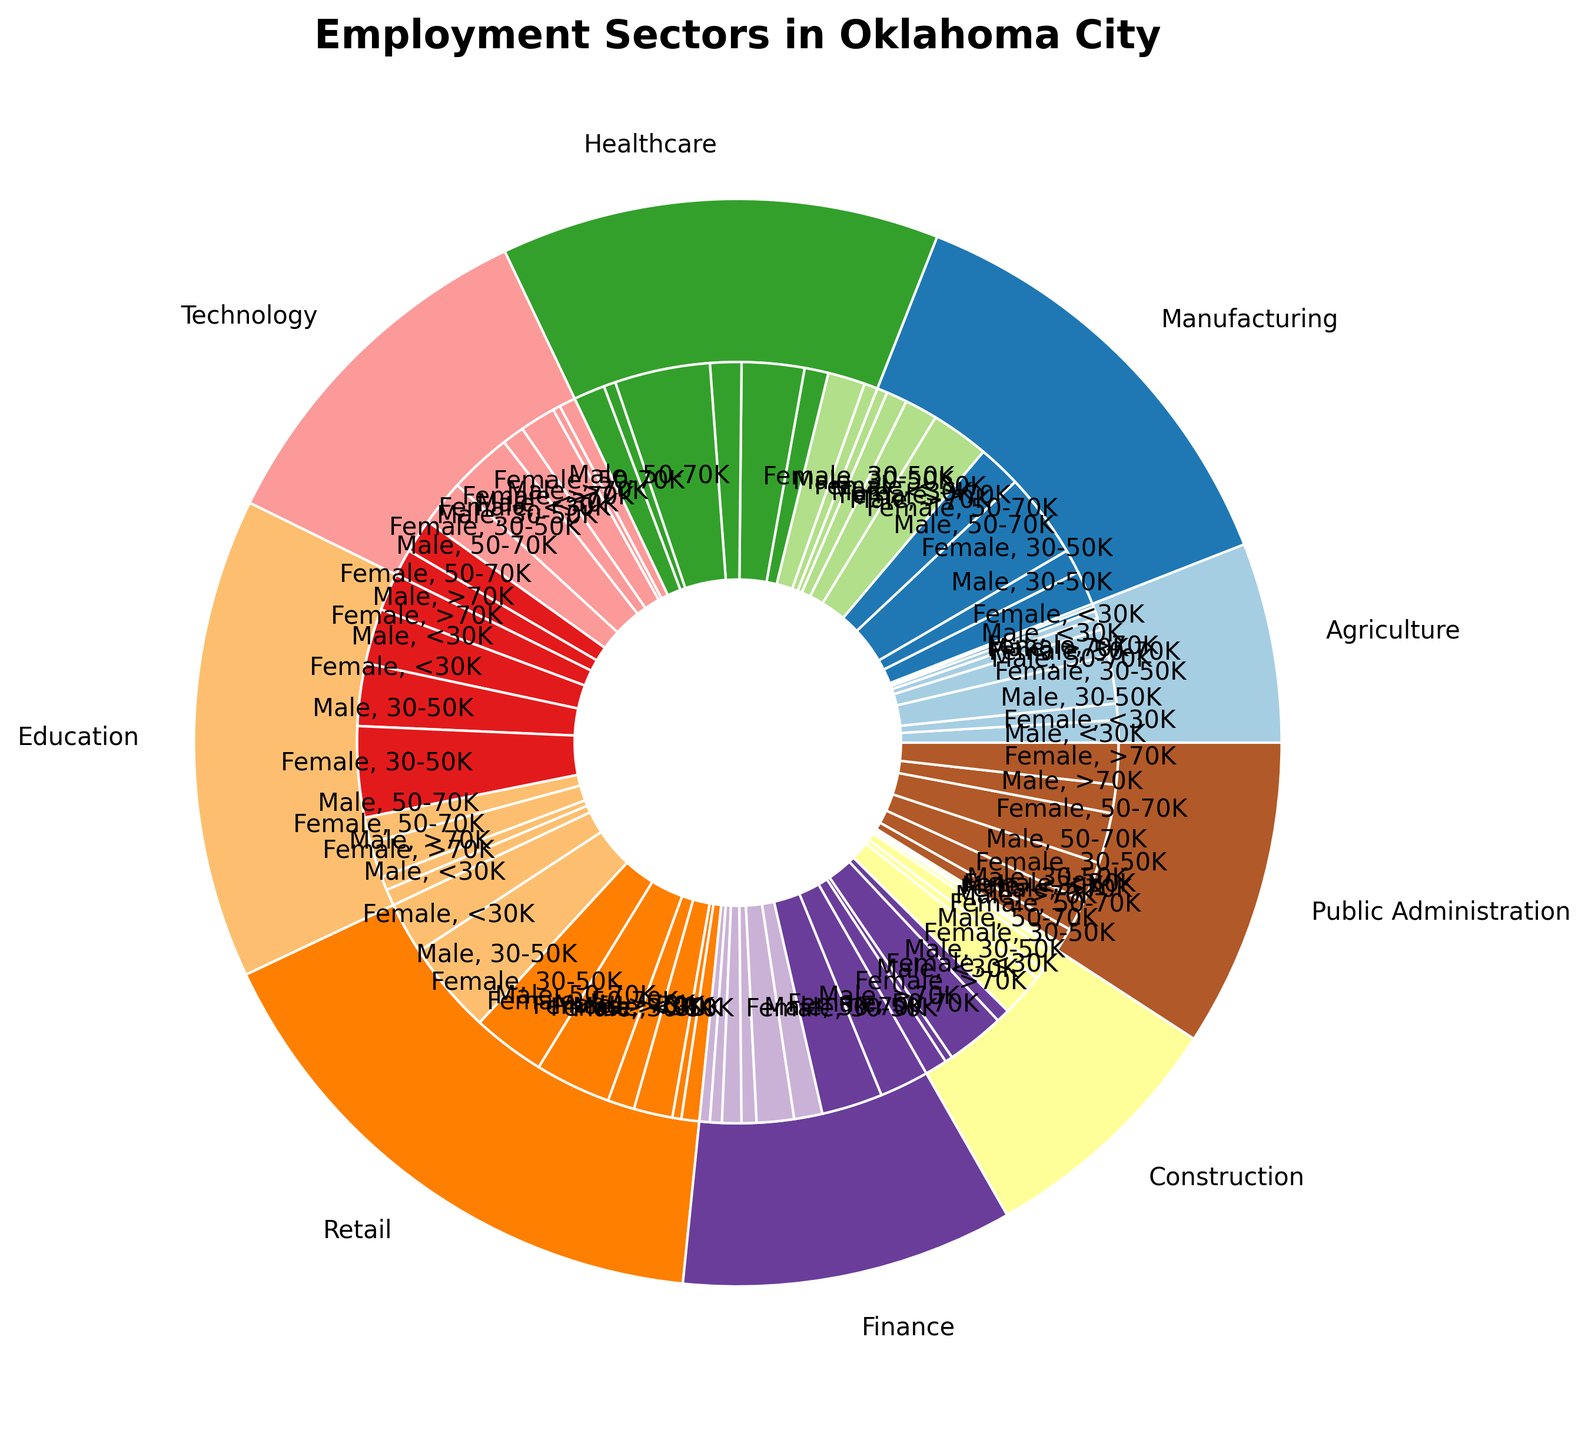How much higher is the representation of males earning above 70K in Finance compared to Construction? First, find the percentage for males earning above 70K in both sectors from the chart. Finance: 4.1%. Construction: 1.2%. Subtract the smaller percentage from the larger one: 4.1% - 1.2% = 2.9%.
Answer: 2.9% In which sector are females earning 30-50K more represented than males? Identify sectors in the chart where the percentage for females in the 30-50K range is higher than that for males. Females are more represented in Education (6.1% vs 4.2%), Healthcare (4.2% vs 1.6%), and Retail (5.1% vs 4.9%).
Answer: Education, Healthcare, Retail Which sector has the smallest overall representation in Oklahoma City? Sum the percentages for all sectors and compare them. Public Administration has the smallest sector sum of 10.3%.
Answer: Public Administration What is the most represented sector for females under 30K? Find the sector with the highest percentage of females earning under 30K by comparing the figures in the chart. Retail has the highest at 6.2%.
Answer: Retail What's the total percentage of people working in Healthcare? Sum the percentages of all categories in Healthcare: 0.9 + 2.5 + 1.6 + 4.2 + 2.1 + 6.4 + 0.8 + 2.1 = 20.6%.
Answer: 20.6% Compare male representation between Agriculture and Technology in the 50-70K range. Look at the chart to find the percentages: Agriculture (0.8%), Technology (4.2%). Technology has a higher representation.
Answer: Technology In which sector do females have a higher percentage than males in all salary ranges? Check each sector and compare percentages for all salary ranges. In Healthcare, females have higher percentages than males in all ranges: <30K (2.5% vs 0.9%), 30-50K (4.2% vs 1.6%), 50-70K (6.4% vs 2.1%), >70K (2.1% vs 0.8%).
Answer: Healthcare What's the average percentage of males and females working in Public Administration? First, sum all percentages for Public Administration: 0.2 + 0.3 + 1.1 + 2.1 + 2.7 + 3.4 + 1.9 + 2.8 = 14.5%. There are 8 categories. Average: 14.5% / 8 = 1.81%.
Answer: 1.81% Which gender is more represented in the 50-70K range in Technology? Compare the percentages for males and females in Technology in the 50-70K range: Males 4.2%, Females 3.1%. Males are more represented.
Answer: Males What is the combined percentage of people earning more than 70K in Construction and Education? Add the percentages: Construction males 1.2% + females 0.4% + Education males 0.9% + females 1.1% = 3.6%.
Answer: 3.6% 